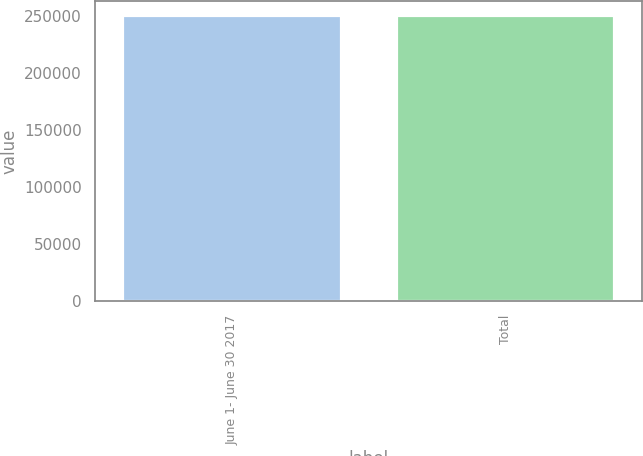Convert chart to OTSL. <chart><loc_0><loc_0><loc_500><loc_500><bar_chart><fcel>June 1- June 30 2017<fcel>Total<nl><fcel>250345<fcel>250345<nl></chart> 